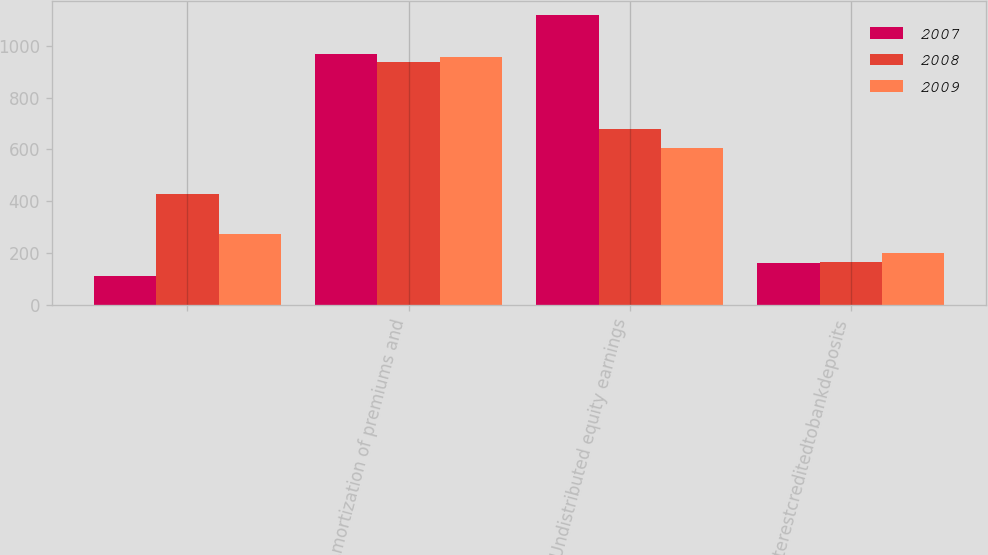<chart> <loc_0><loc_0><loc_500><loc_500><stacked_bar_chart><ecel><fcel>Unnamed: 1<fcel>Amortization of premiums and<fcel>Undistributed equity earnings<fcel>Interestcreditedtobankdeposits<nl><fcel>2007<fcel>110<fcel>967<fcel>1118<fcel>163<nl><fcel>2008<fcel>428<fcel>939<fcel>679<fcel>166<nl><fcel>2009<fcel>275<fcel>955<fcel>606<fcel>200<nl></chart> 